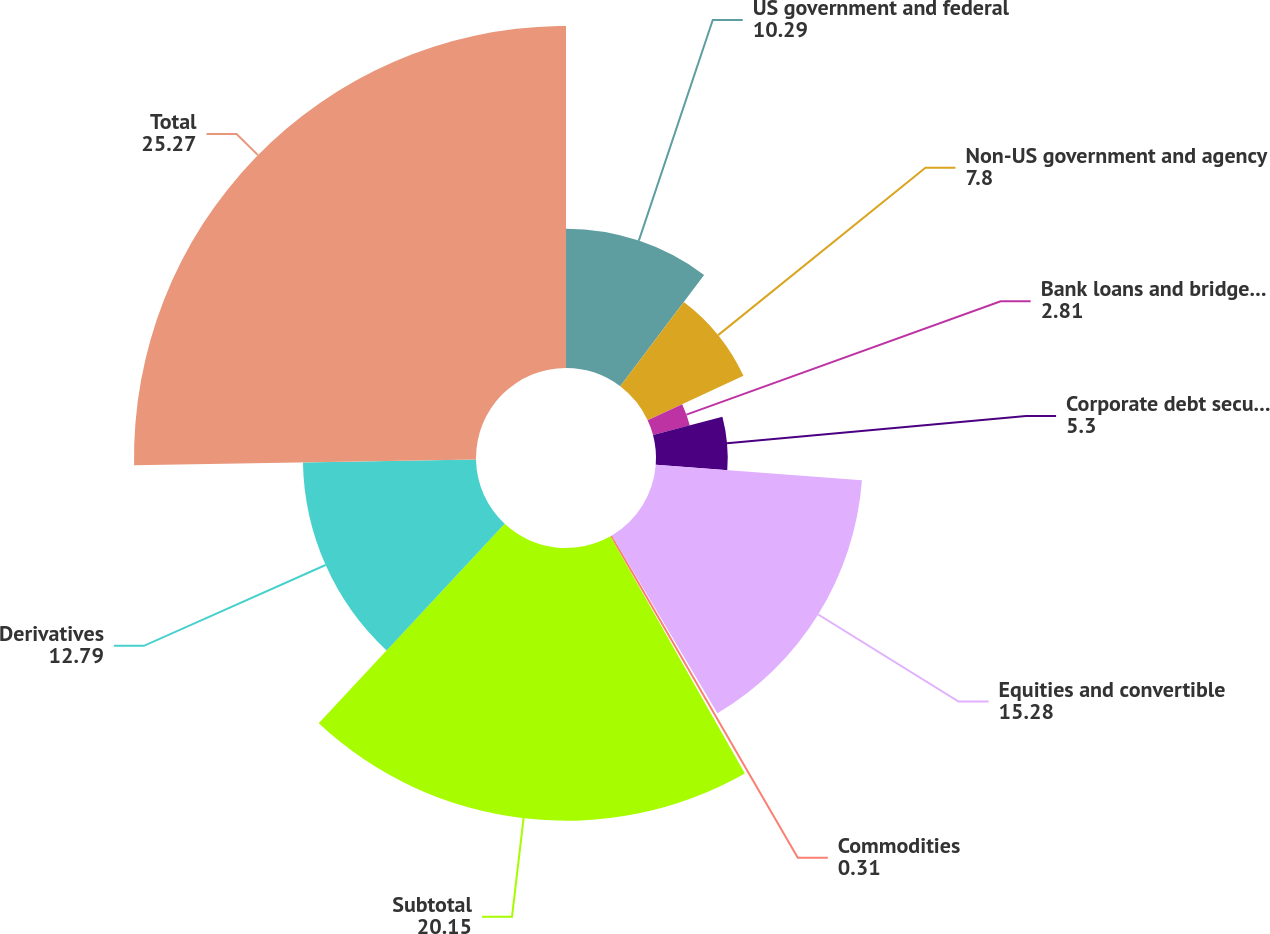Convert chart to OTSL. <chart><loc_0><loc_0><loc_500><loc_500><pie_chart><fcel>US government and federal<fcel>Non-US government and agency<fcel>Bank loans and bridge loans<fcel>Corporate debt securities<fcel>Equities and convertible<fcel>Commodities<fcel>Subtotal<fcel>Derivatives<fcel>Total<nl><fcel>10.29%<fcel>7.8%<fcel>2.81%<fcel>5.3%<fcel>15.28%<fcel>0.31%<fcel>20.15%<fcel>12.79%<fcel>25.27%<nl></chart> 